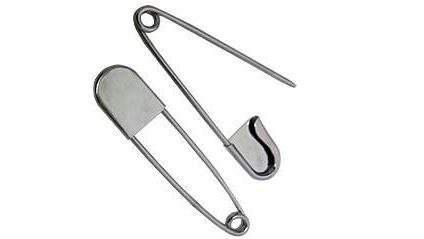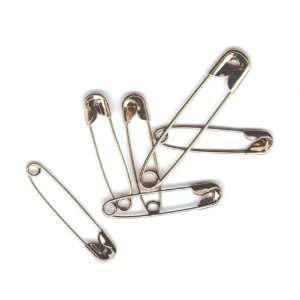The first image is the image on the left, the second image is the image on the right. For the images shown, is this caption "An image shows overlapping safety pins." true? Answer yes or no. Yes. The first image is the image on the left, the second image is the image on the right. Analyze the images presented: Is the assertion "There are more pins in the image on the right." valid? Answer yes or no. Yes. 